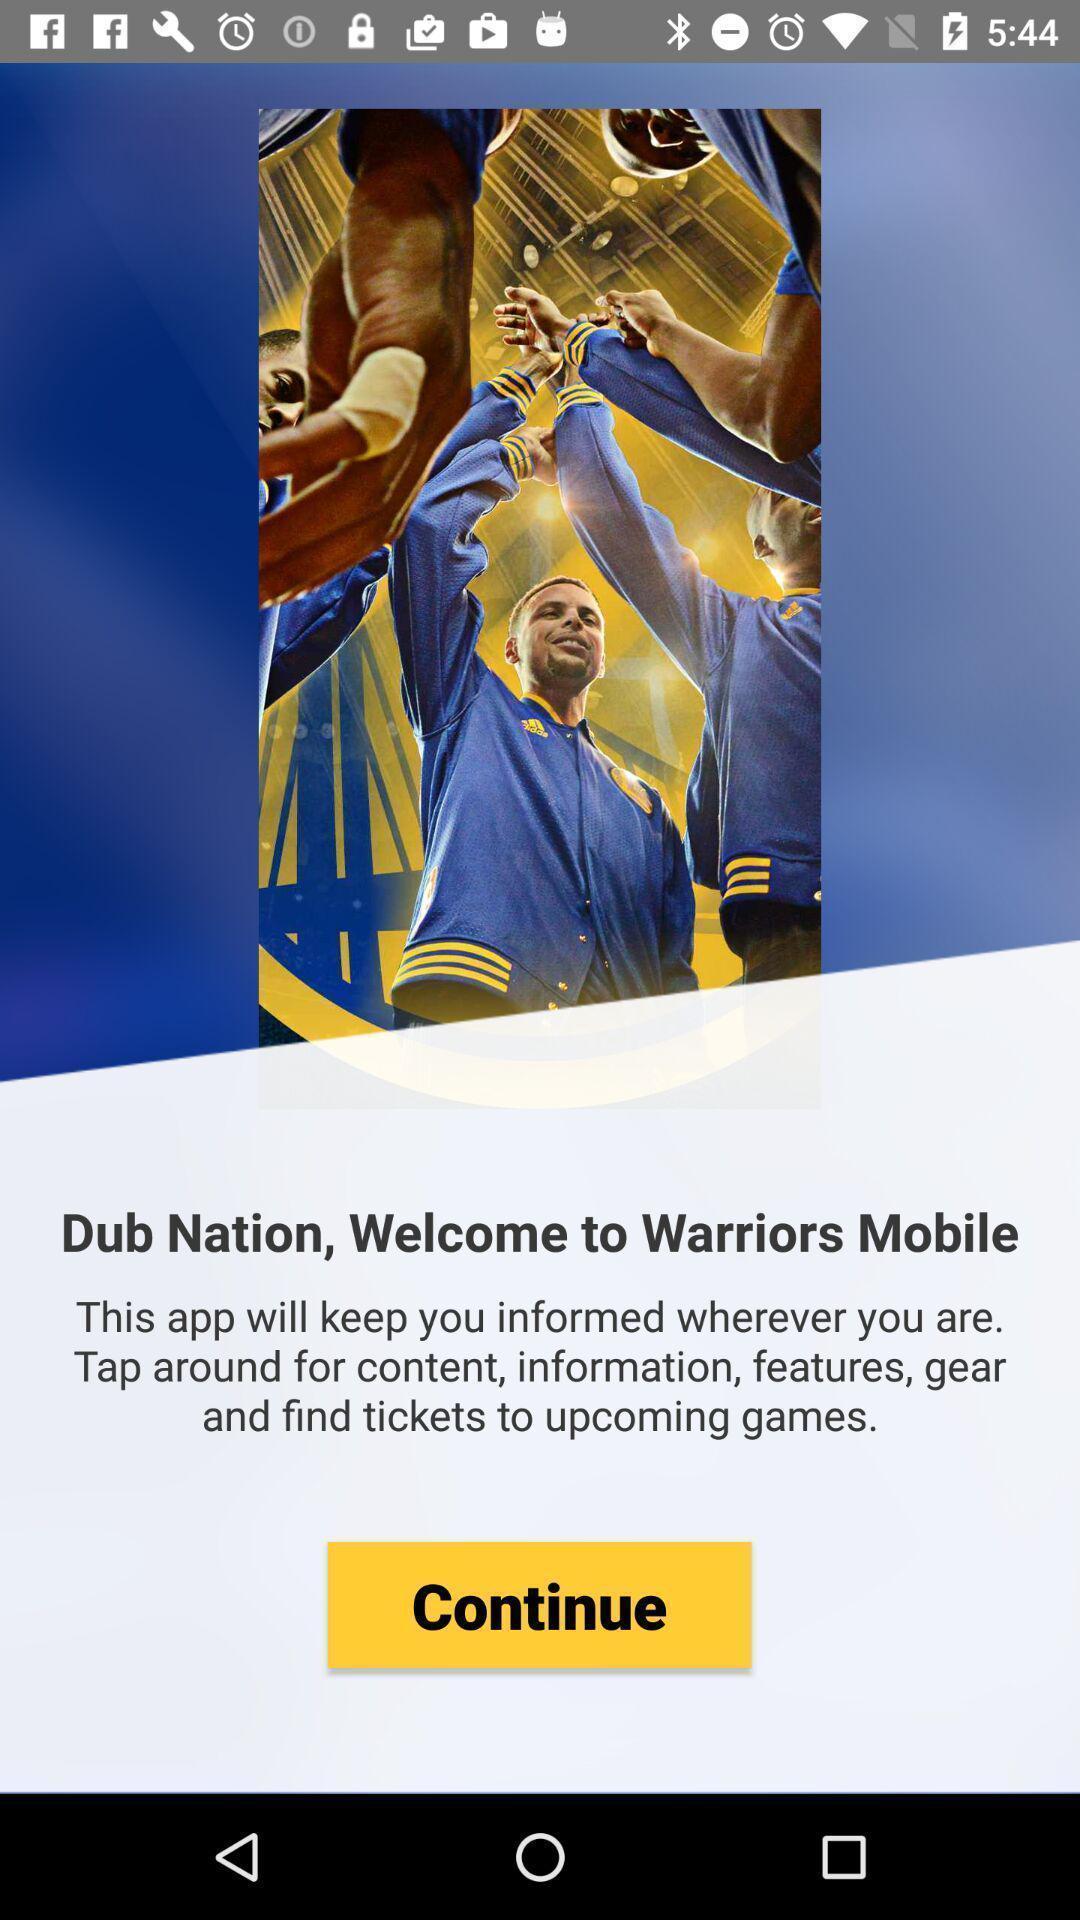Tell me about the visual elements in this screen capture. Welcome page. 